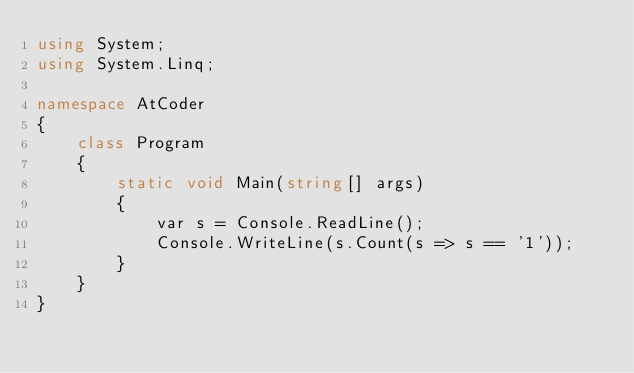<code> <loc_0><loc_0><loc_500><loc_500><_C#_>using System;
using System.Linq;

namespace AtCoder
{
    class Program
    {
        static void Main(string[] args)
        {
            var s = Console.ReadLine();
            Console.WriteLine(s.Count(s => s == '1'));
        }
    }
}</code> 